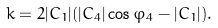Convert formula to latex. <formula><loc_0><loc_0><loc_500><loc_500>k = 2 | C _ { 1 } | ( | C _ { 4 } | \cos \varphi _ { 4 } - | C _ { 1 } | ) .</formula> 